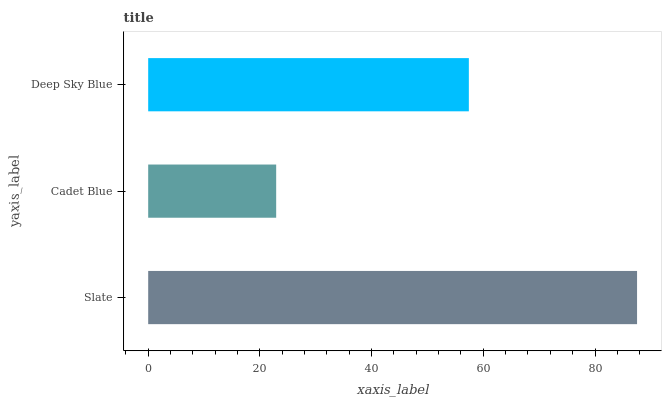Is Cadet Blue the minimum?
Answer yes or no. Yes. Is Slate the maximum?
Answer yes or no. Yes. Is Deep Sky Blue the minimum?
Answer yes or no. No. Is Deep Sky Blue the maximum?
Answer yes or no. No. Is Deep Sky Blue greater than Cadet Blue?
Answer yes or no. Yes. Is Cadet Blue less than Deep Sky Blue?
Answer yes or no. Yes. Is Cadet Blue greater than Deep Sky Blue?
Answer yes or no. No. Is Deep Sky Blue less than Cadet Blue?
Answer yes or no. No. Is Deep Sky Blue the high median?
Answer yes or no. Yes. Is Deep Sky Blue the low median?
Answer yes or no. Yes. Is Slate the high median?
Answer yes or no. No. Is Slate the low median?
Answer yes or no. No. 